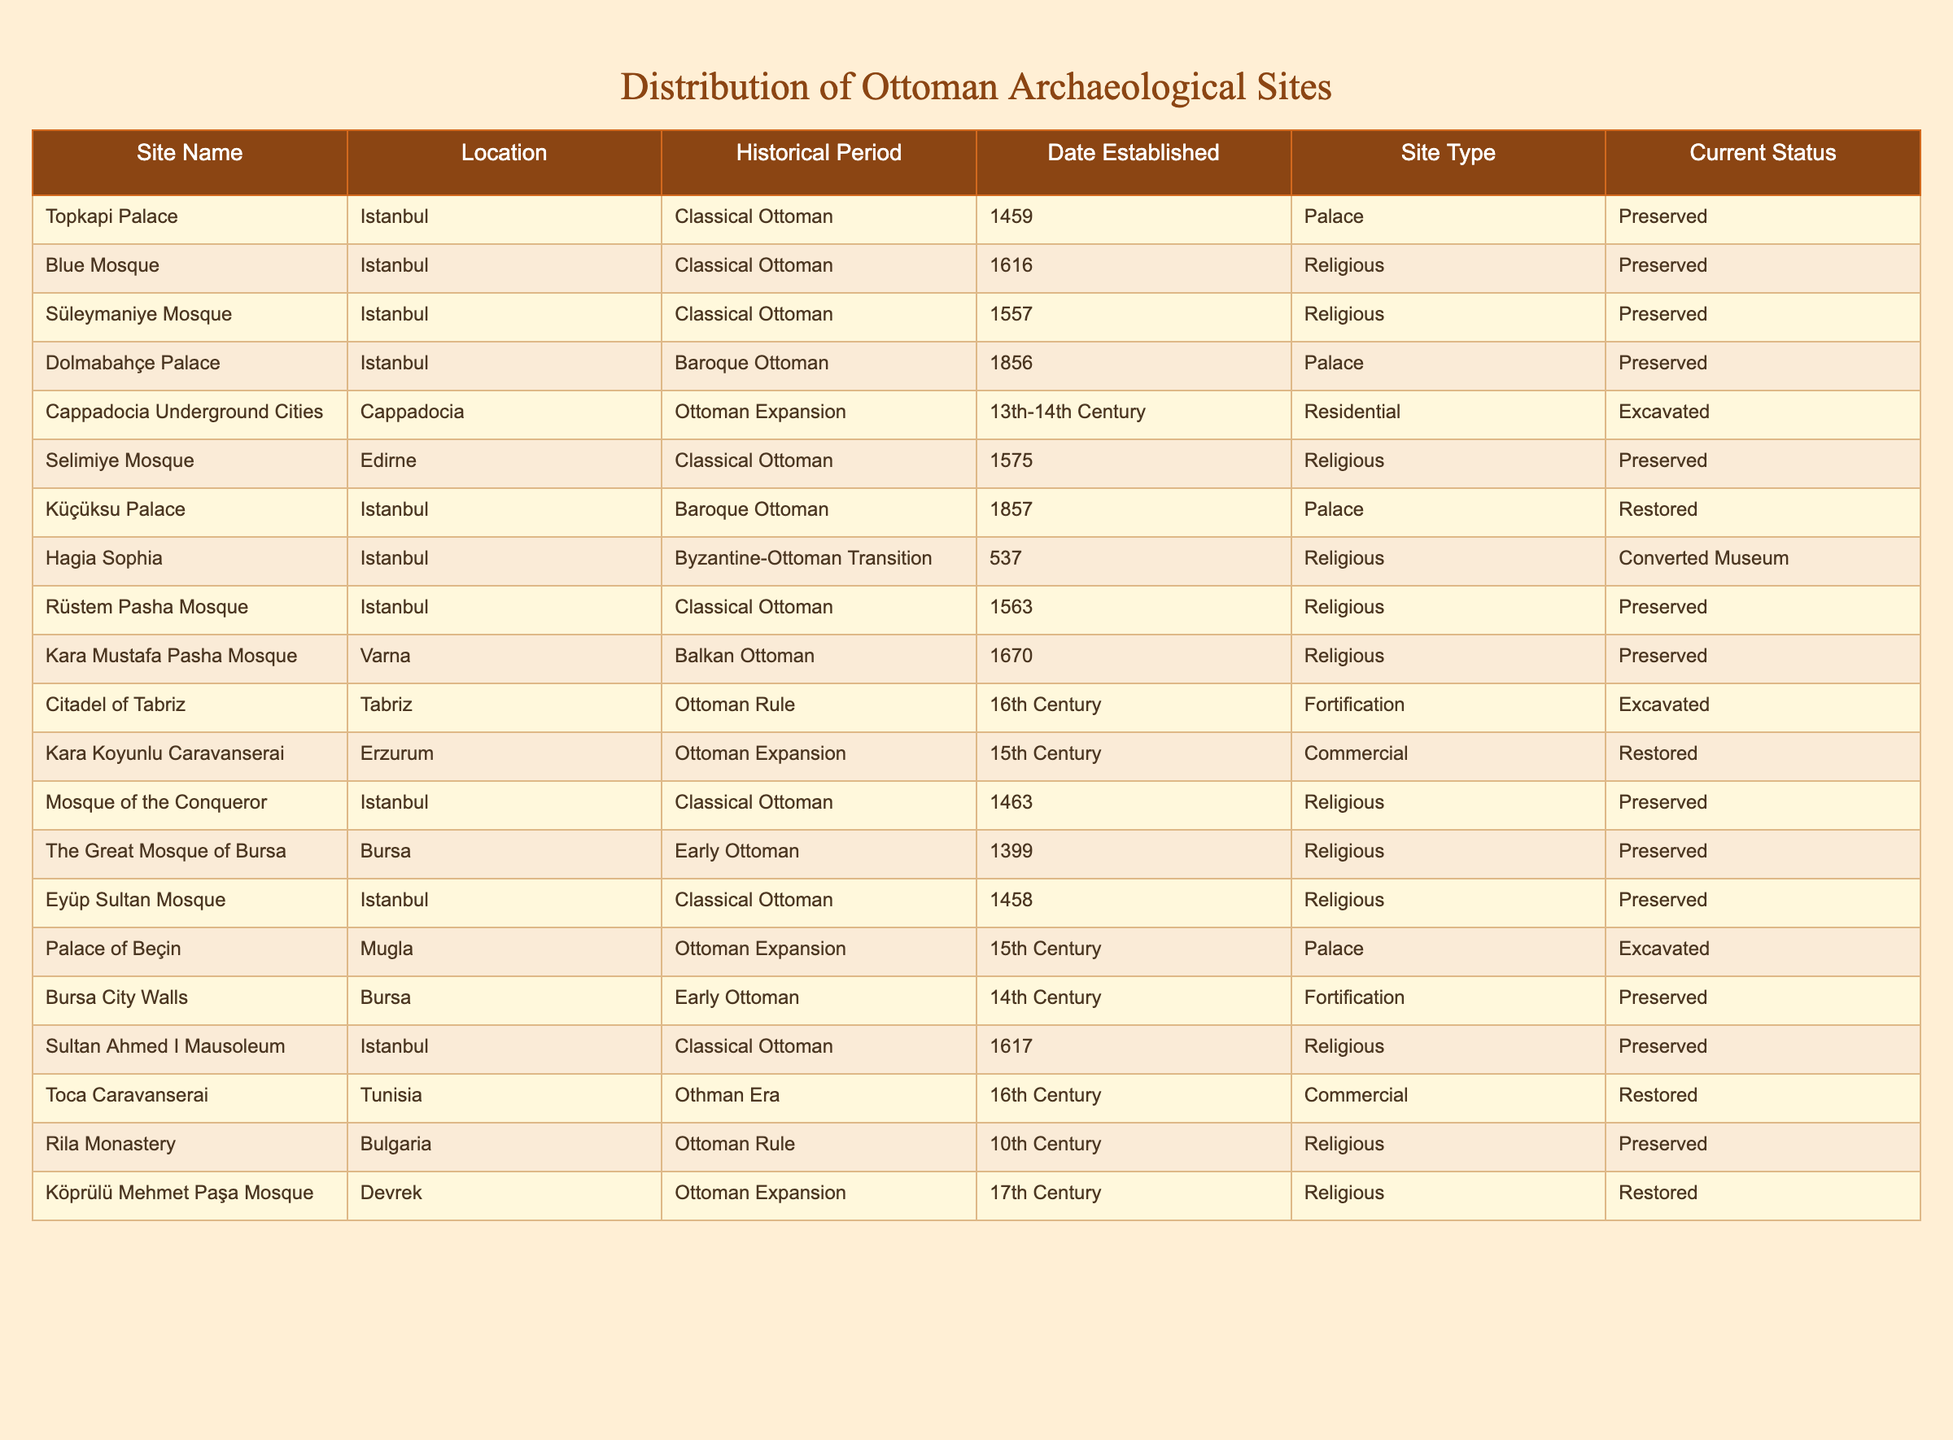What is the location of the Süleymaniye Mosque? The table lists the location of each archaeological site. By locating the Süleymaniye Mosque in the table, it shows that it is in Istanbul.
Answer: Istanbul How many archaeological sites are classified as 'Palace'? The table counts the number of entries with 'Palace' listed under the Site Type. There are three entries: Topkapi Palace, Dolmabahçe Palace, and Küçüksu Palace.
Answer: 3 Is there a mosque established in the 17th Century listed in the table? To find this, I check the Date Established column for any mosque entries from the 17th Century. The Köprülü Mehmet Paşa Mosque with that date is present, confirming the existence.
Answer: Yes Which historical period has the most archaeological sites? I will count the occurrences for each historical period in the table. Classical Ottoman has the highest count with six sites, as compared to others.
Answer: Classical Ottoman What is the current status of the Hagia Sophia? Referring to the Current Status column, I see that the Hagia Sophia is labeled as 'Converted Museum.'
Answer: Converted Museum How many sites in the Early Ottoman period are located in Bursa? The table shows two sites from the Early Ottoman period located in Bursa: The Great Mosque of Bursa and Bursa City Walls, totaling them gives an answer.
Answer: 2 What is the average date established year for the Baroque Ottoman Period sites? The table shows two Baroque Ottoman sites with established years 1856 and 1857. Calculating the average: (1856 + 1857) / 2 = 1856.5.
Answer: 1856.5 Is the Rüstem Pasha Mosque preserved? I will check the Current Status column for the Rüstem Pasha Mosque and see that it's listed as 'Preserved.'
Answer: Yes Which site was established first, the Blue Mosque or the Süleymaniye Mosque? Comparing the Date Established values for both mosques, the Blue Mosque dates to 1616, while the Süleymaniye Mosque is at 1557. Therefore, the Süleymaniye Mosque is earlier.
Answer: Süleymaniye Mosque How many types of structures are represented in the table? I will look at the Site Type column. The unique types found are Palace, Religious, Residential, Commercial, and Fortification, which totals five different types.
Answer: 5 